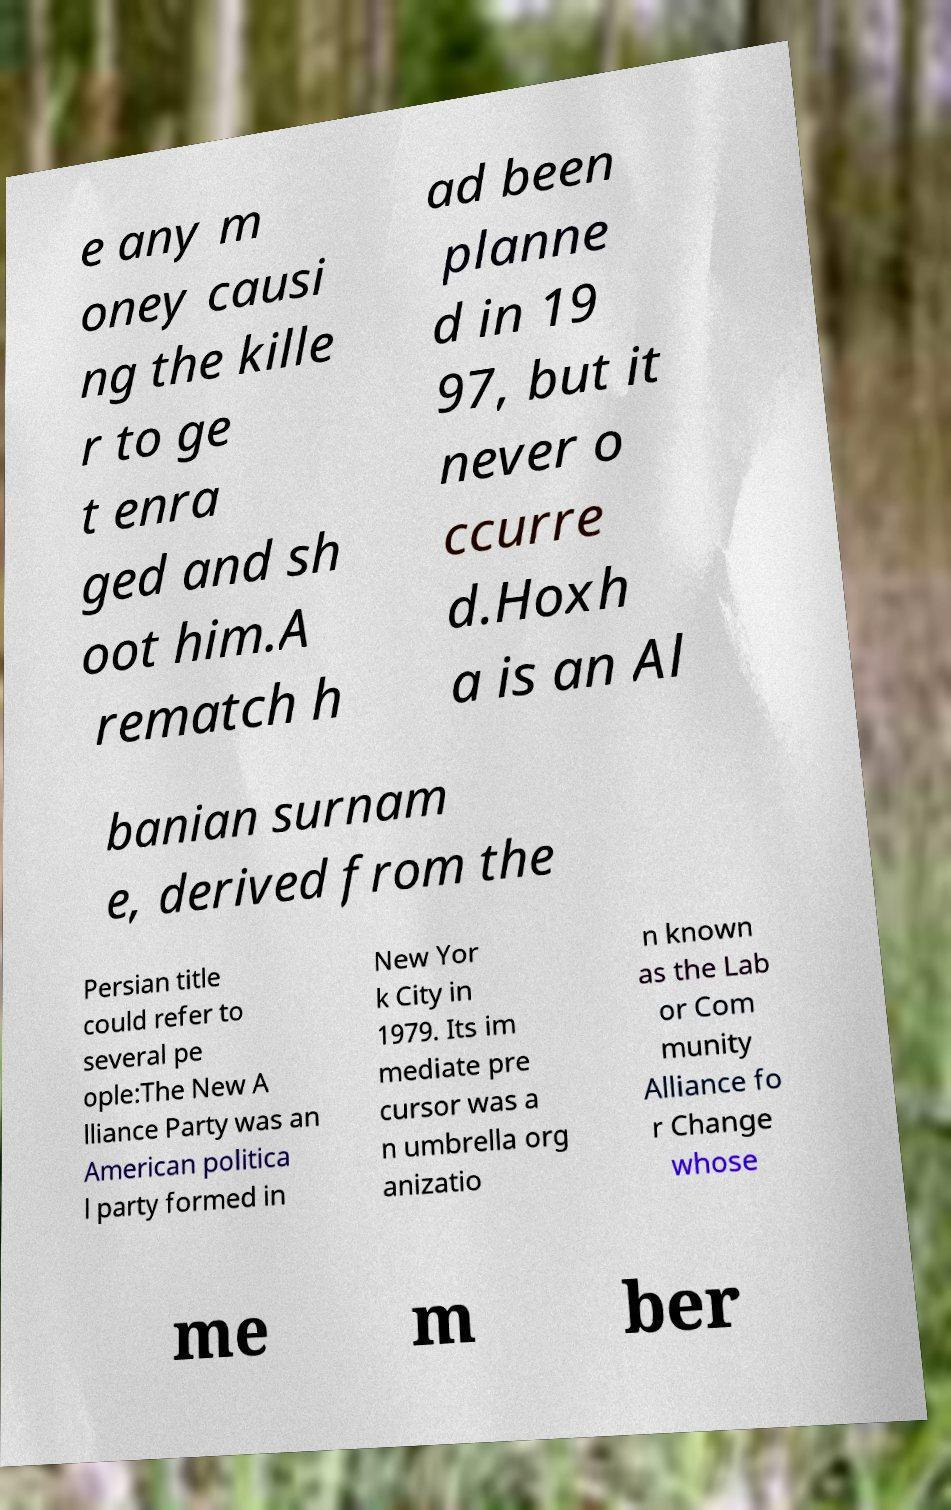There's text embedded in this image that I need extracted. Can you transcribe it verbatim? e any m oney causi ng the kille r to ge t enra ged and sh oot him.A rematch h ad been planne d in 19 97, but it never o ccurre d.Hoxh a is an Al banian surnam e, derived from the Persian title could refer to several pe ople:The New A lliance Party was an American politica l party formed in New Yor k City in 1979. Its im mediate pre cursor was a n umbrella org anizatio n known as the Lab or Com munity Alliance fo r Change whose me m ber 